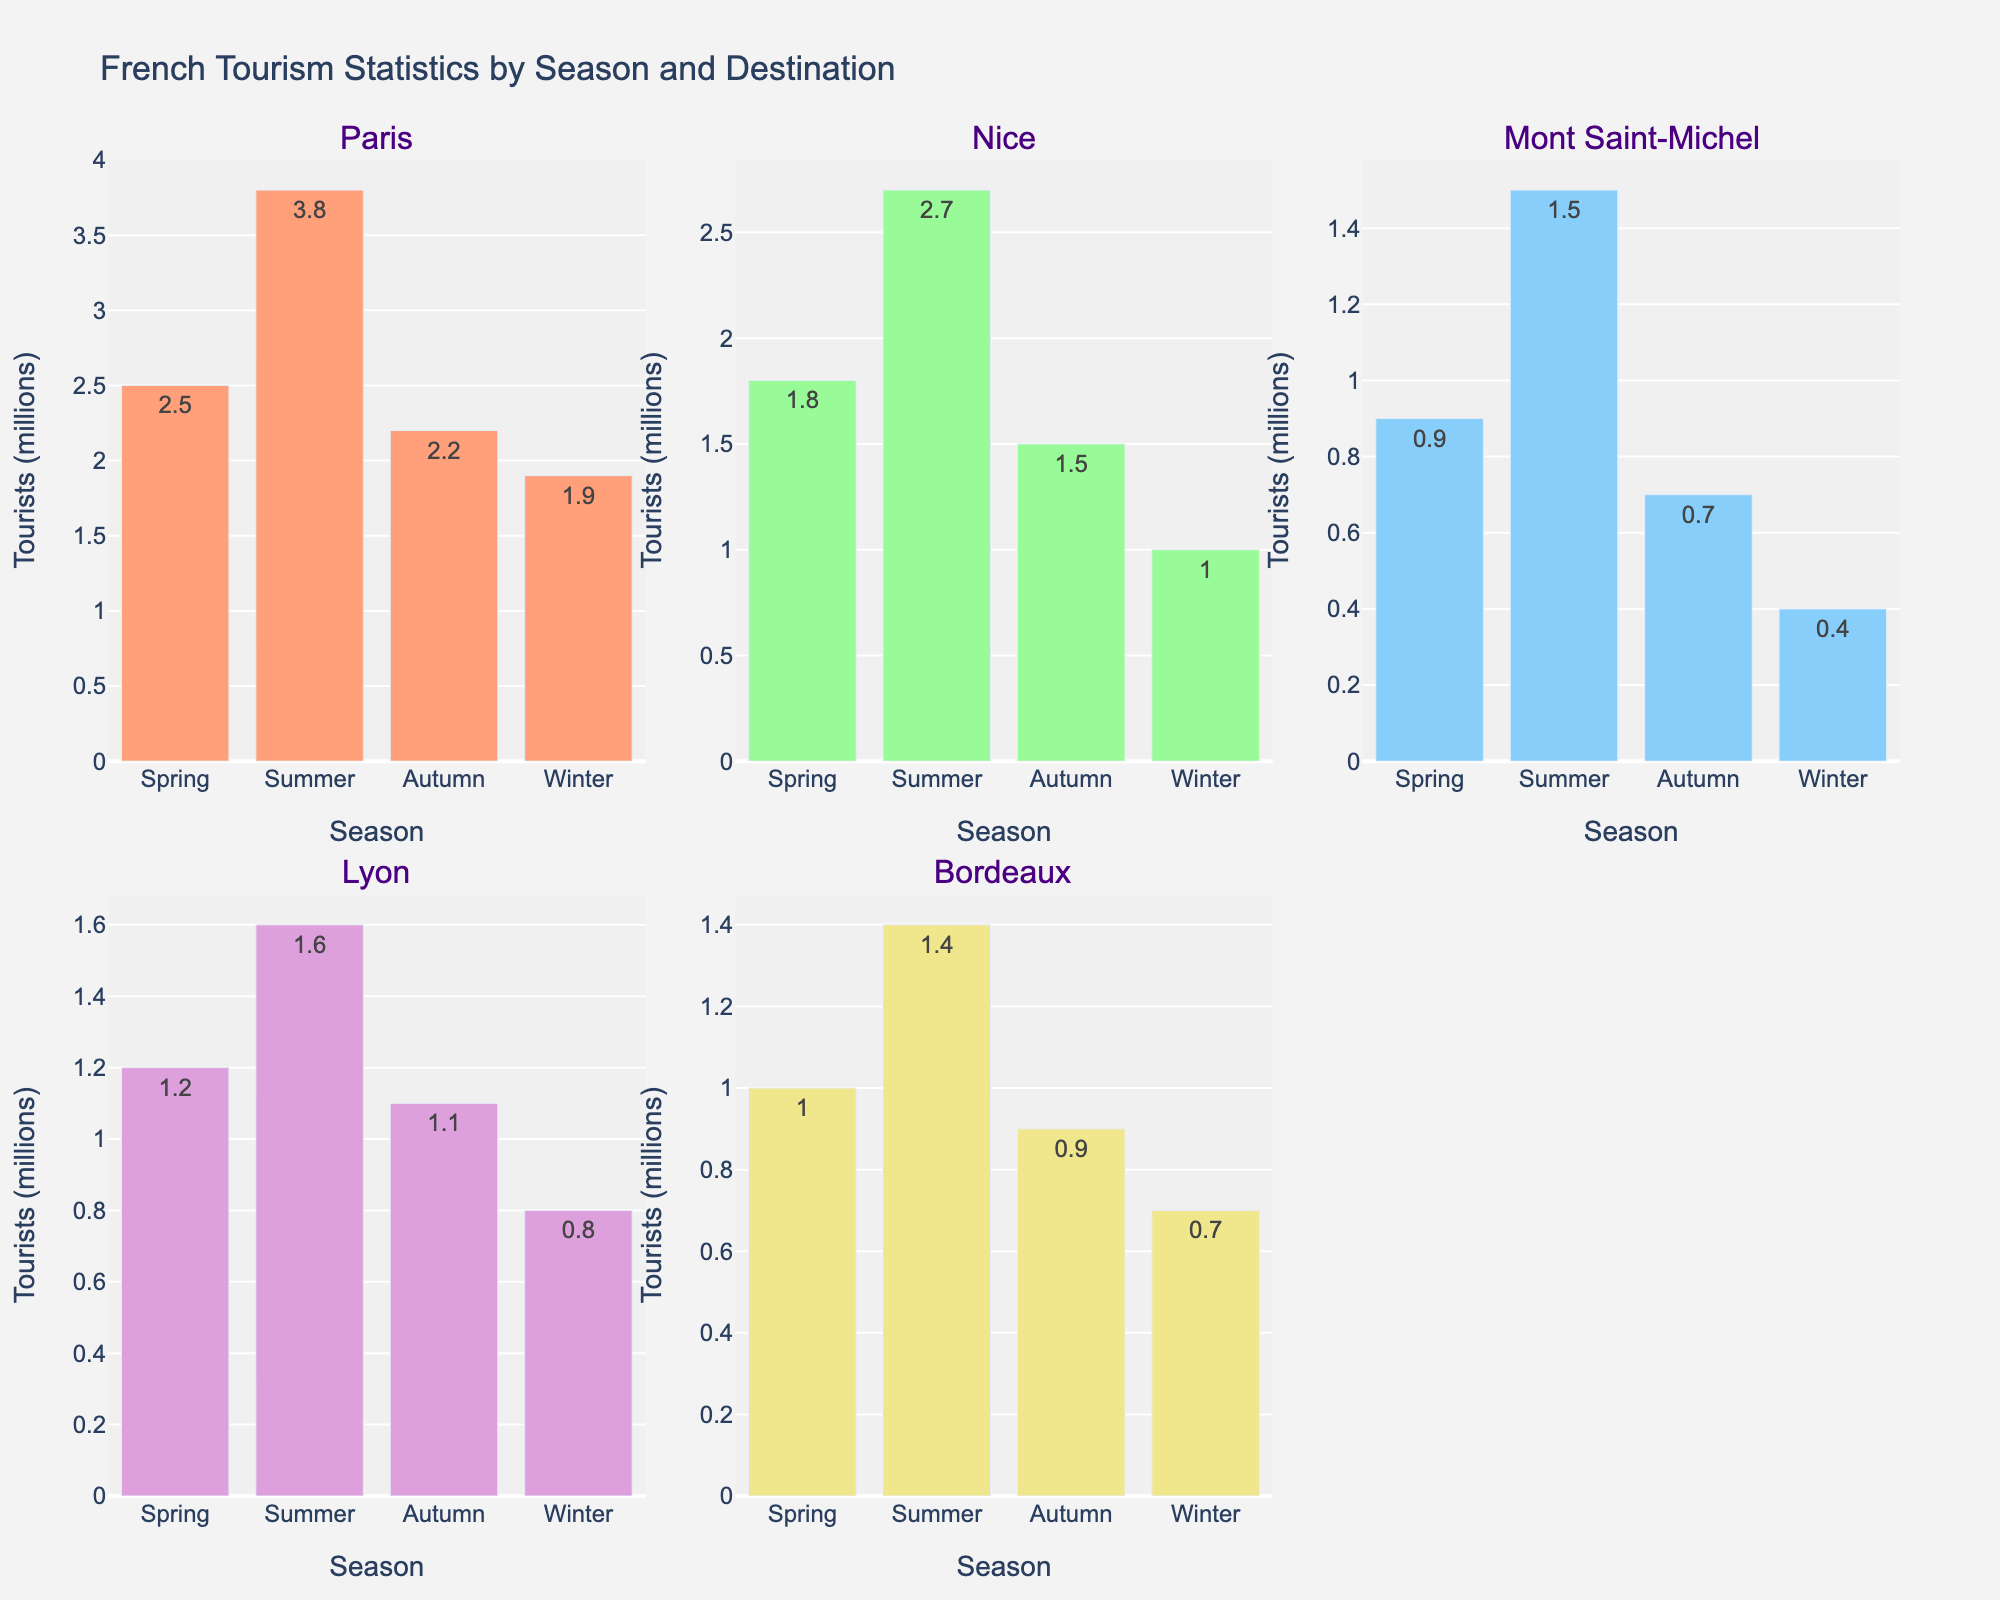what is the title of the figure? The title of the figure is located at the top center. It reads "French Tourism Statistics by Season and Destination".
Answer: French Tourism Statistics by Season and Destination which season has the highest number of tourists in Paris? The bar for the summer season in the Paris subplot is the tallest, indicating the highest number of tourists.
Answer: Summer what is the combined number of tourists for Nice and Lyon in winter? To find the combined number of tourists, add the winter values for Nice (1.0) and Lyon (0.8). The sum is 1.8 million tourists.
Answer: 1.8 is the number of tourists in Bordeaux higher in spring or autumn? By comparing the height of the bars in the Bordeaux subplot, the spring bar (1.0 million) is taller than the autumn bar (0.9 million), indicating more tourists in spring.
Answer: Spring provide the season when Mont Saint-Michel receives the least tourists. The shortest bar in the Mont Saint-Michel subplot represents the winter season, with 0.4 million tourists, the least across all seasons.
Answer: Winter compare the difference in tourist numbers between spring and autumn in Paris. Subtract the autumn value (2.2 million) from the spring value (2.5 million) to get the difference, which is 0.3 million.
Answer: 0.3 in which destination does the number of tourists fluctuate the most between summer and winter? The differences between summer and winter tourist numbers are: Paris (3.8-1.9=1.9), Nice (2.7-1.0=1.7), Mont Saint-Michel (1.5-0.4=1.1), Lyon (1.6-0.8=0.8), Bordeaux (1.4-0.7=0.7). Paris has the highest fluctuation of 1.9 million tourists.
Answer: Paris identify which destination has the smallest variance in tourist numbers across all seasons. Calculate the range for each destination: Paris (3.8-1.9=1.9), Nice (2.7-1.0=1.7), Mont Saint-Michel (1.5-0.4=1.1), Lyon (1.6-0.8=0.8), Bordeaux (1.4-0.7=0.7). Bordeaux, with the smallest range of 0.7 million, has the smallest variance.
Answer: Bordeaux find the average number of tourists visiting Lyon each season. Sum the tourist numbers for Lyon across all seasons (1.2+1.6+1.1+0.8=4.7) and divide by the number of seasons (4). The average is 4.7 / 4 = 1.175 million tourists.
Answer: 1.175 